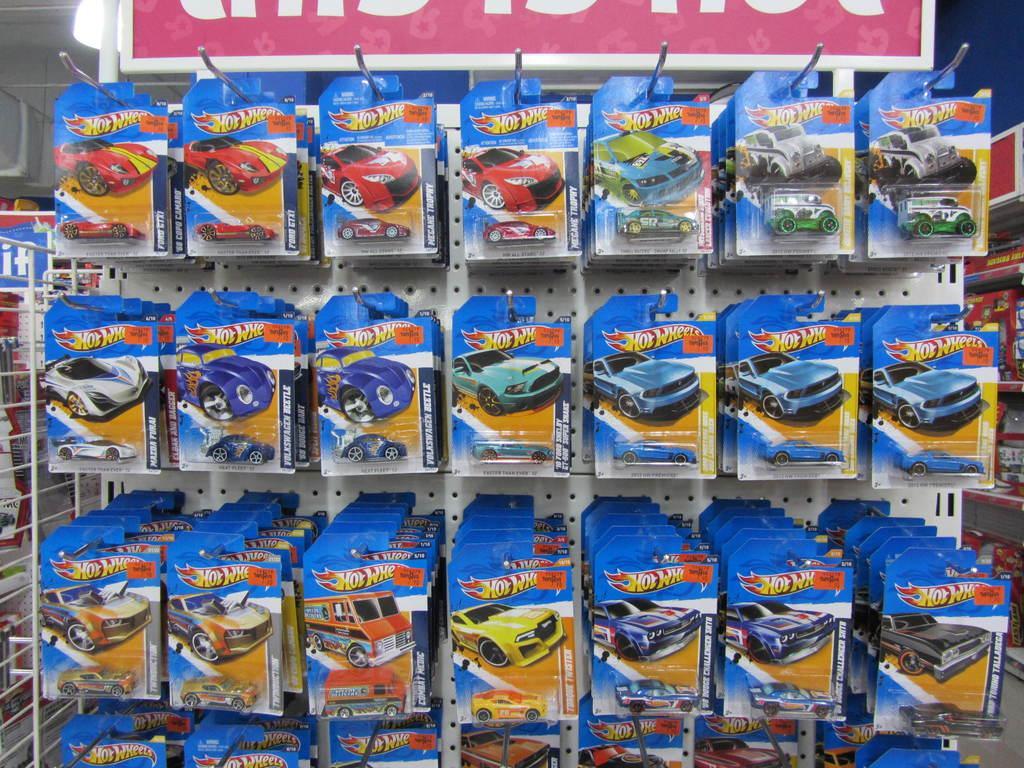Can you describe this image briefly? In the center of the image we can see toys placed in a shelves. 